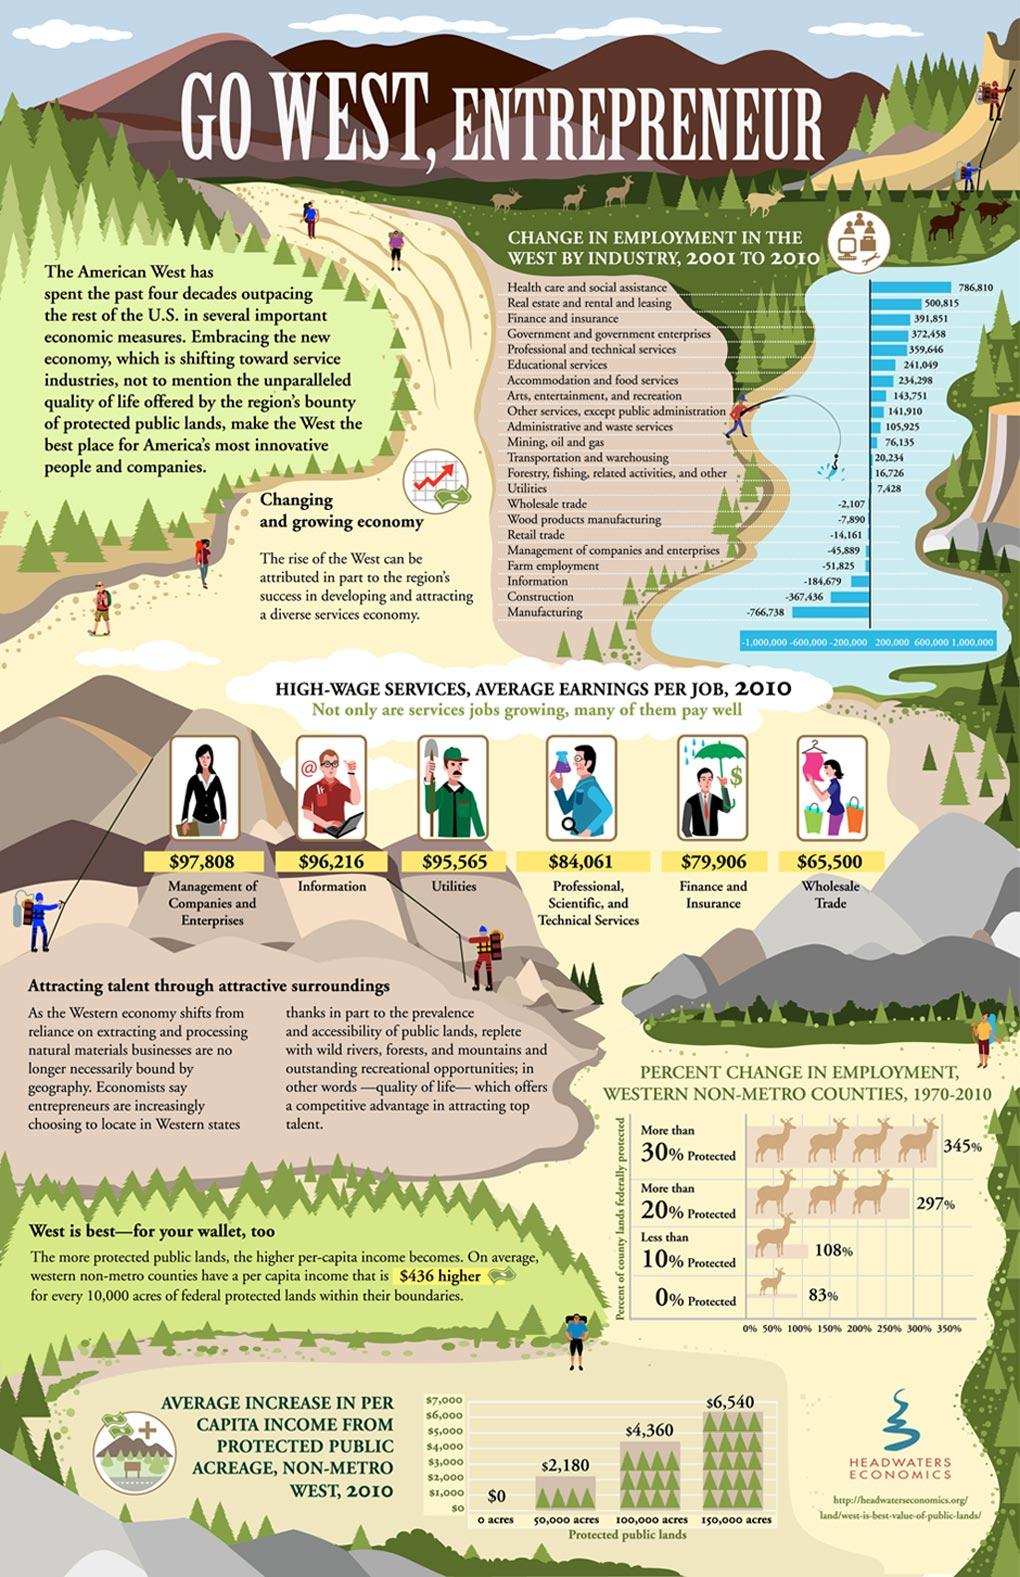Highlight a few significant elements in this photo. The wage for utility services is $95,565. According to the information, the wage for information services is approximately $96,216. The total wage for information and utility services in 191781 is... 